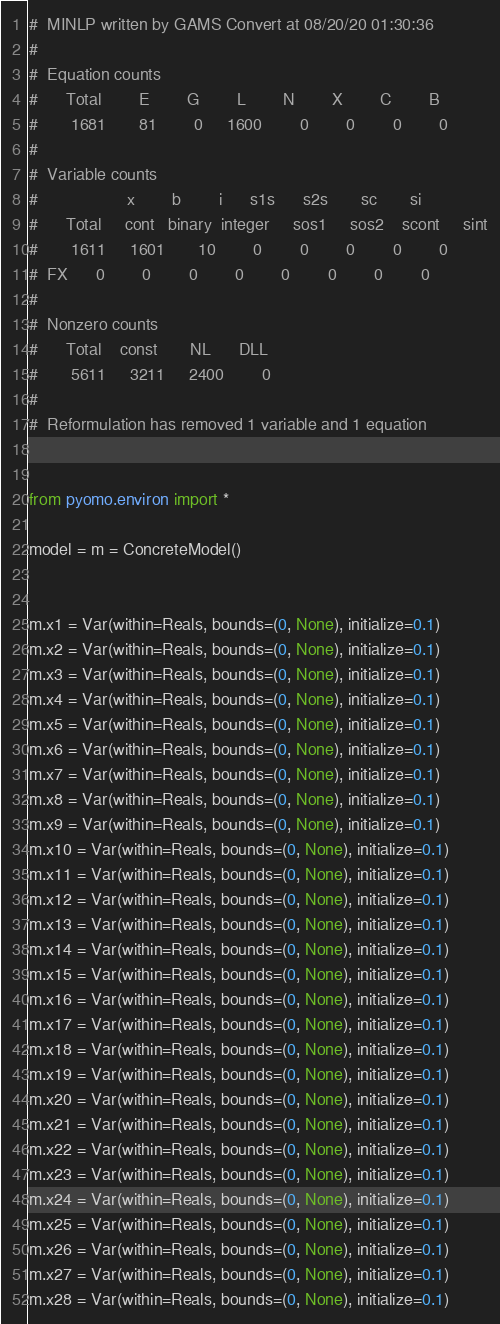<code> <loc_0><loc_0><loc_500><loc_500><_Python_>#  MINLP written by GAMS Convert at 08/20/20 01:30:36
#
#  Equation counts
#      Total        E        G        L        N        X        C        B
#       1681       81        0     1600        0        0        0        0
#
#  Variable counts
#                   x        b        i      s1s      s2s       sc       si
#      Total     cont   binary  integer     sos1     sos2    scont     sint
#       1611     1601       10        0        0        0        0        0
#  FX      0        0        0        0        0        0        0        0
#
#  Nonzero counts
#      Total    const       NL      DLL
#       5611     3211     2400        0
#
#  Reformulation has removed 1 variable and 1 equation


from pyomo.environ import *

model = m = ConcreteModel()


m.x1 = Var(within=Reals, bounds=(0, None), initialize=0.1)
m.x2 = Var(within=Reals, bounds=(0, None), initialize=0.1)
m.x3 = Var(within=Reals, bounds=(0, None), initialize=0.1)
m.x4 = Var(within=Reals, bounds=(0, None), initialize=0.1)
m.x5 = Var(within=Reals, bounds=(0, None), initialize=0.1)
m.x6 = Var(within=Reals, bounds=(0, None), initialize=0.1)
m.x7 = Var(within=Reals, bounds=(0, None), initialize=0.1)
m.x8 = Var(within=Reals, bounds=(0, None), initialize=0.1)
m.x9 = Var(within=Reals, bounds=(0, None), initialize=0.1)
m.x10 = Var(within=Reals, bounds=(0, None), initialize=0.1)
m.x11 = Var(within=Reals, bounds=(0, None), initialize=0.1)
m.x12 = Var(within=Reals, bounds=(0, None), initialize=0.1)
m.x13 = Var(within=Reals, bounds=(0, None), initialize=0.1)
m.x14 = Var(within=Reals, bounds=(0, None), initialize=0.1)
m.x15 = Var(within=Reals, bounds=(0, None), initialize=0.1)
m.x16 = Var(within=Reals, bounds=(0, None), initialize=0.1)
m.x17 = Var(within=Reals, bounds=(0, None), initialize=0.1)
m.x18 = Var(within=Reals, bounds=(0, None), initialize=0.1)
m.x19 = Var(within=Reals, bounds=(0, None), initialize=0.1)
m.x20 = Var(within=Reals, bounds=(0, None), initialize=0.1)
m.x21 = Var(within=Reals, bounds=(0, None), initialize=0.1)
m.x22 = Var(within=Reals, bounds=(0, None), initialize=0.1)
m.x23 = Var(within=Reals, bounds=(0, None), initialize=0.1)
m.x24 = Var(within=Reals, bounds=(0, None), initialize=0.1)
m.x25 = Var(within=Reals, bounds=(0, None), initialize=0.1)
m.x26 = Var(within=Reals, bounds=(0, None), initialize=0.1)
m.x27 = Var(within=Reals, bounds=(0, None), initialize=0.1)
m.x28 = Var(within=Reals, bounds=(0, None), initialize=0.1)</code> 